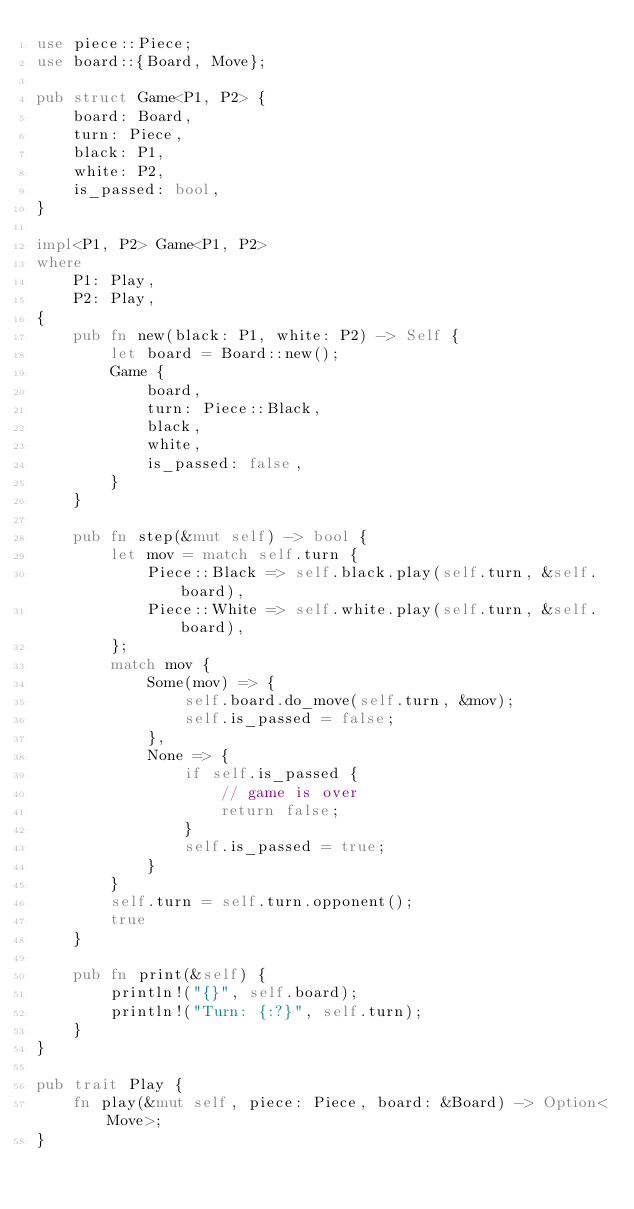<code> <loc_0><loc_0><loc_500><loc_500><_Rust_>use piece::Piece;
use board::{Board, Move};

pub struct Game<P1, P2> {
    board: Board,
    turn: Piece,
    black: P1,
    white: P2,
    is_passed: bool,
}

impl<P1, P2> Game<P1, P2>
where
    P1: Play,
    P2: Play,
{
    pub fn new(black: P1, white: P2) -> Self {
        let board = Board::new();
        Game {
            board,
            turn: Piece::Black,
            black,
            white,
            is_passed: false,
        }
    }

    pub fn step(&mut self) -> bool {
        let mov = match self.turn {
            Piece::Black => self.black.play(self.turn, &self.board),
            Piece::White => self.white.play(self.turn, &self.board),
        };
        match mov {
            Some(mov) => {
                self.board.do_move(self.turn, &mov);
                self.is_passed = false;
            },
            None => {
                if self.is_passed {
                    // game is over
                    return false;
                }
                self.is_passed = true;
            }
        }
        self.turn = self.turn.opponent();
        true
    }

    pub fn print(&self) {
        println!("{}", self.board);
        println!("Turn: {:?}", self.turn);
    }
}

pub trait Play {
    fn play(&mut self, piece: Piece, board: &Board) -> Option<Move>;
}
</code> 